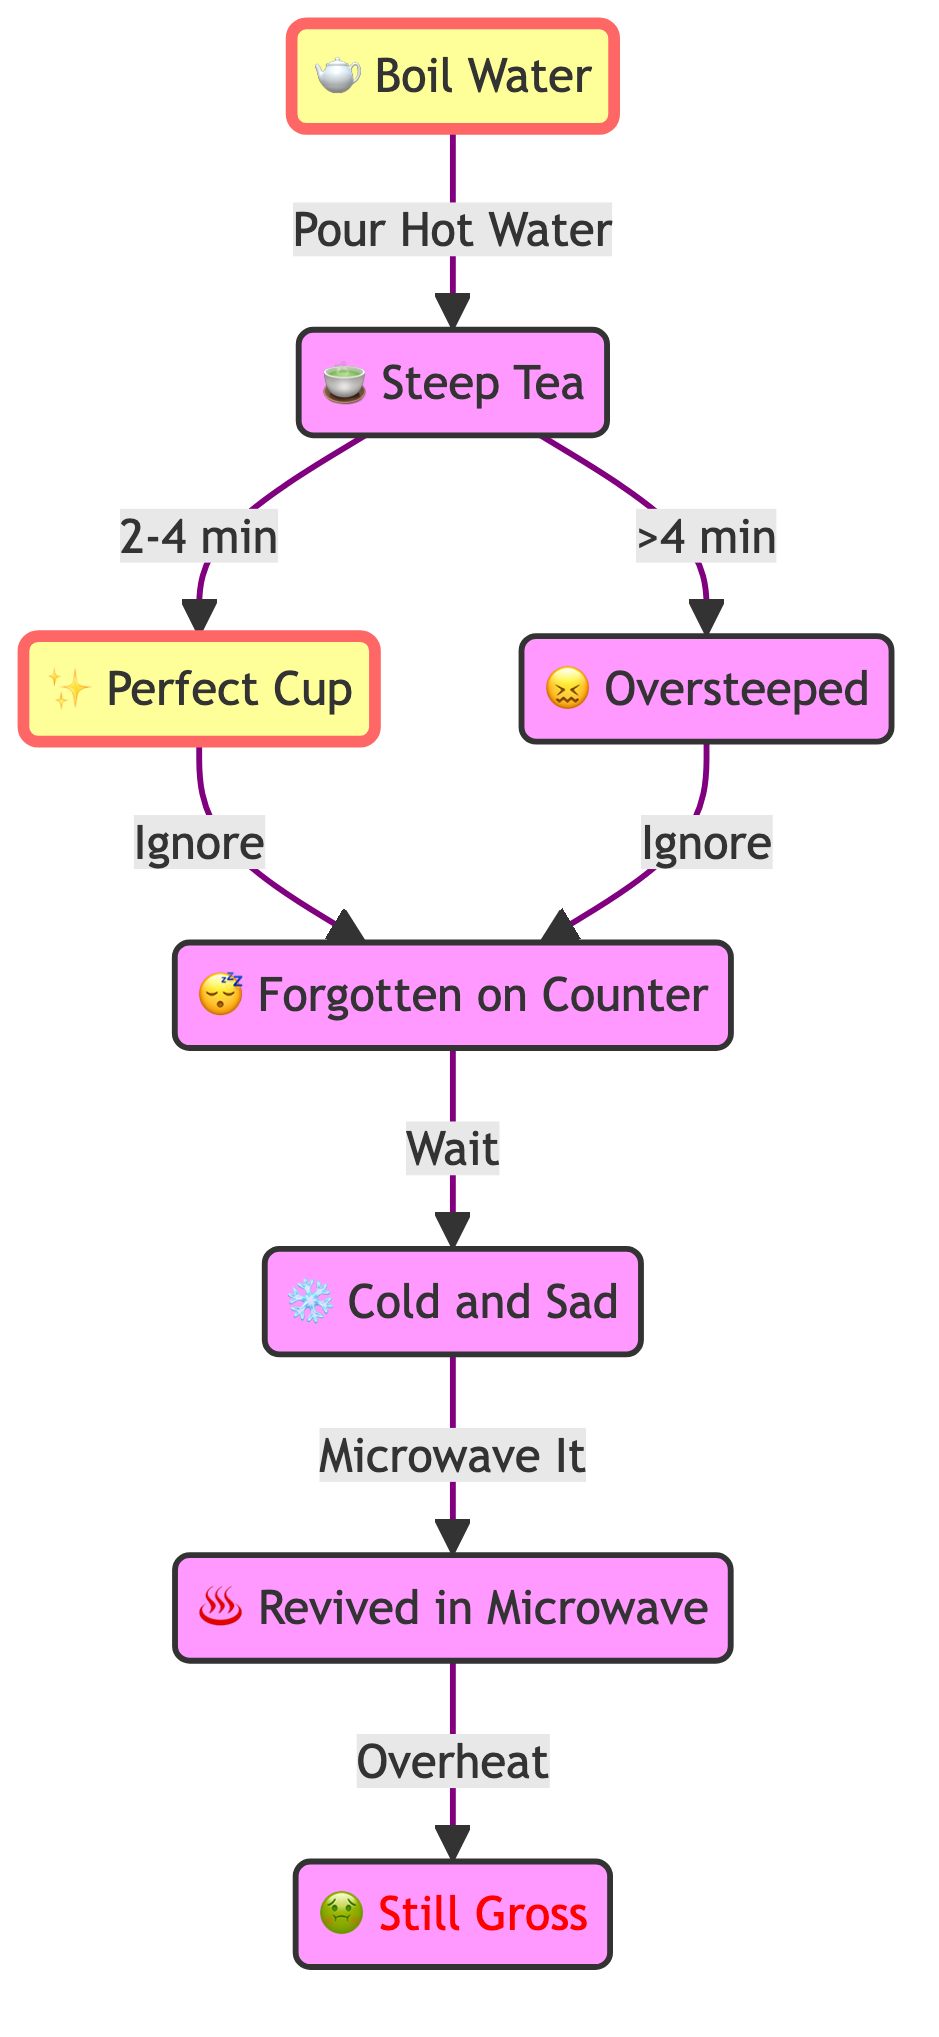What is the first step in the lifecycle of a cup of tea? The first step, as indicated by the flow from the start of the diagram, is "Boil Water".
Answer: Boil Water How many stages are there in the lifecycle of a cup of tea? Counting all distinct stages shown in the diagram, there are a total of 7 stages.
Answer: 7 What happens after the tea is steeped for more than 4 minutes? The diagram shows that if tea is steeped for more than 4 minutes, the next stage reached is "Oversteeped".
Answer: Oversteeped What is the consequence of microwaving cold tea? According to the flow, if cold tea is microwaved, it could lead to the stage "Still Gross" if overheated.
Answer: Still Gross Which phase is reached if the perfect cup of tea is ignored? If the "Perfect Cup" is ignored, the next stage is "Forgotten on Counter".
Answer: Forgotten on Counter If you steep tea for 2-4 minutes, what is the result? Steeping tea for 2-4 minutes leads to the "Perfect Cup" stage, as indicated in the diagram.
Answer: Perfect Cup What is the connection between "Cold and Sad" and "Revived in Microwave"? The diagram shows that the "Cold and Sad" stage leads directly to the "Revived in Microwave" stage when microwaved.
Answer: Revived in Microwave What node follows the "Counter Tea" stage? The next node that follows "Counter Tea" is "Cold and Sad" after waiting.
Answer: Cold and Sad 